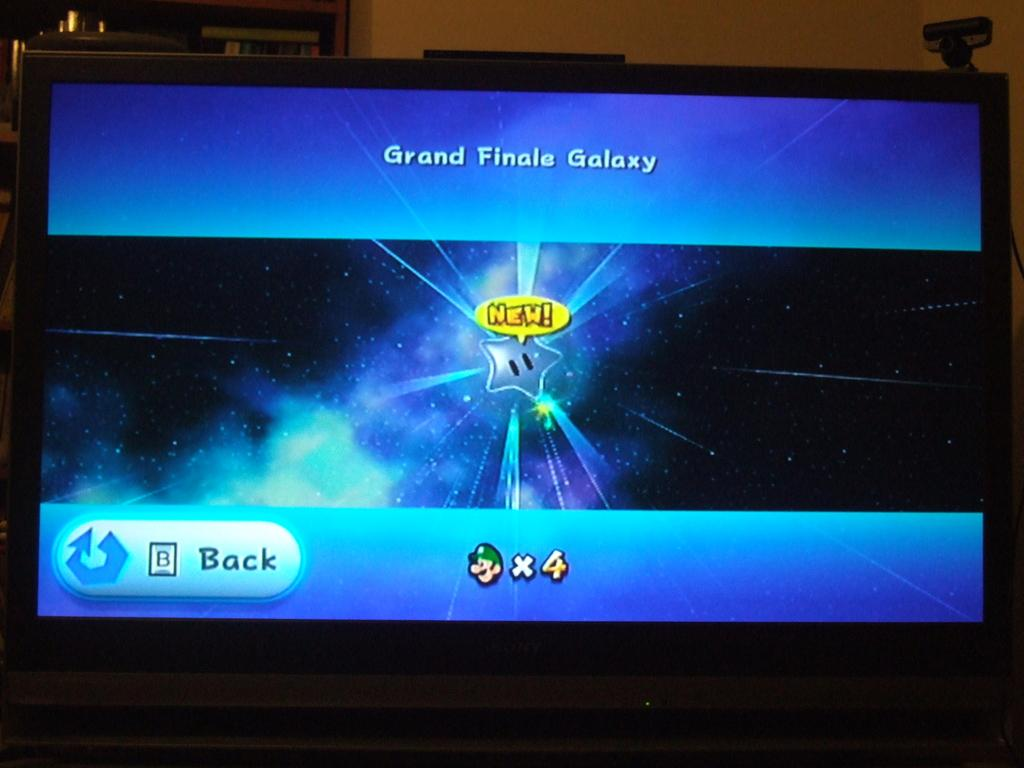<image>
Summarize the visual content of the image. A screen for the Grand Finale Galaxy shows Luigi at the bottom. 